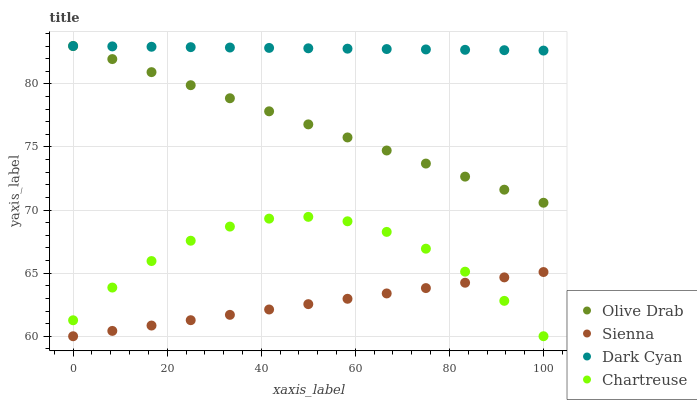Does Sienna have the minimum area under the curve?
Answer yes or no. Yes. Does Dark Cyan have the maximum area under the curve?
Answer yes or no. Yes. Does Chartreuse have the minimum area under the curve?
Answer yes or no. No. Does Chartreuse have the maximum area under the curve?
Answer yes or no. No. Is Olive Drab the smoothest?
Answer yes or no. Yes. Is Chartreuse the roughest?
Answer yes or no. Yes. Is Dark Cyan the smoothest?
Answer yes or no. No. Is Dark Cyan the roughest?
Answer yes or no. No. Does Sienna have the lowest value?
Answer yes or no. Yes. Does Chartreuse have the lowest value?
Answer yes or no. No. Does Olive Drab have the highest value?
Answer yes or no. Yes. Does Chartreuse have the highest value?
Answer yes or no. No. Is Sienna less than Olive Drab?
Answer yes or no. Yes. Is Dark Cyan greater than Chartreuse?
Answer yes or no. Yes. Does Chartreuse intersect Sienna?
Answer yes or no. Yes. Is Chartreuse less than Sienna?
Answer yes or no. No. Is Chartreuse greater than Sienna?
Answer yes or no. No. Does Sienna intersect Olive Drab?
Answer yes or no. No. 